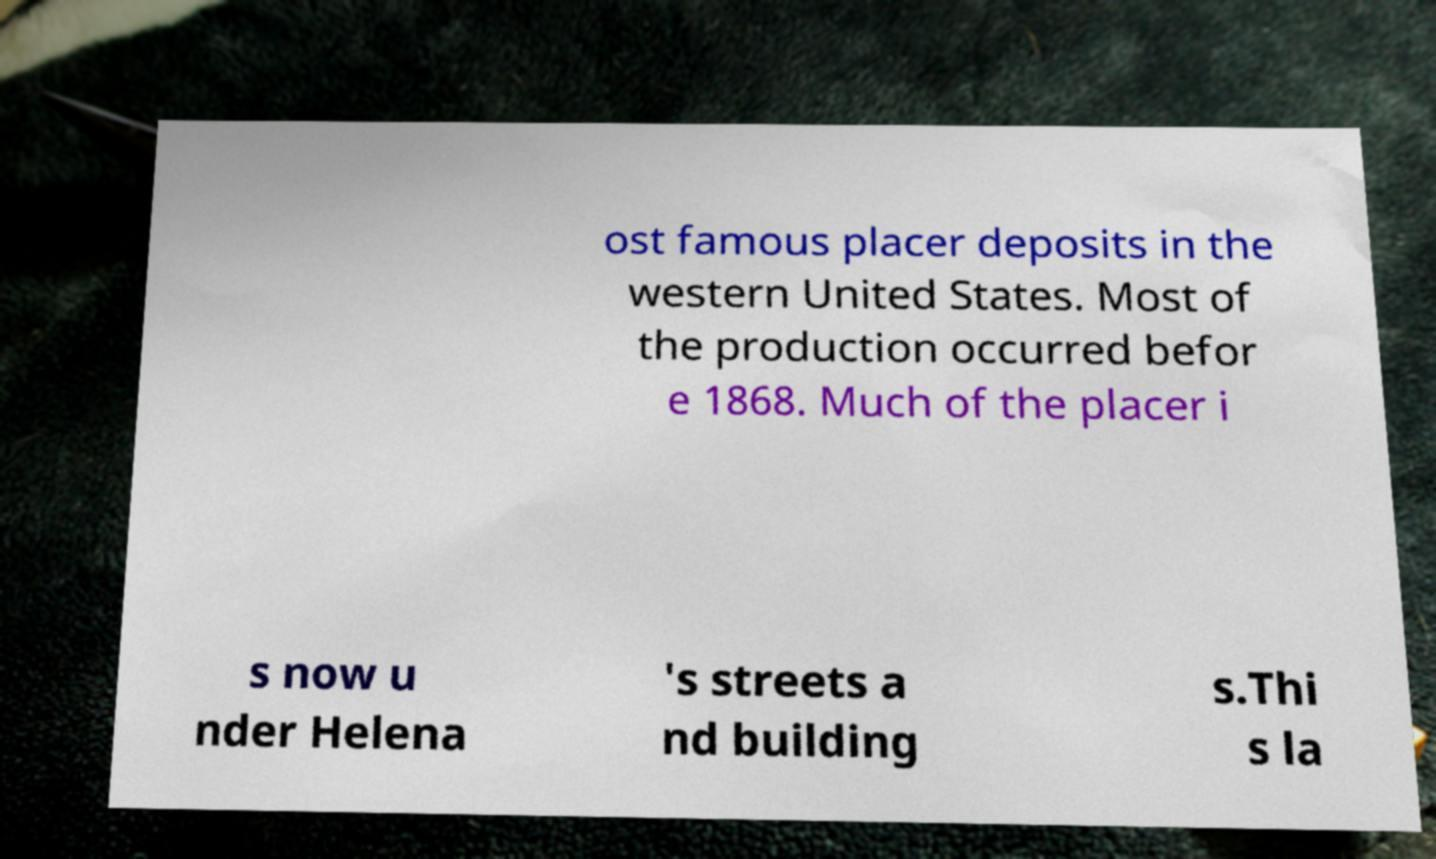Could you assist in decoding the text presented in this image and type it out clearly? ost famous placer deposits in the western United States. Most of the production occurred befor e 1868. Much of the placer i s now u nder Helena 's streets a nd building s.Thi s la 